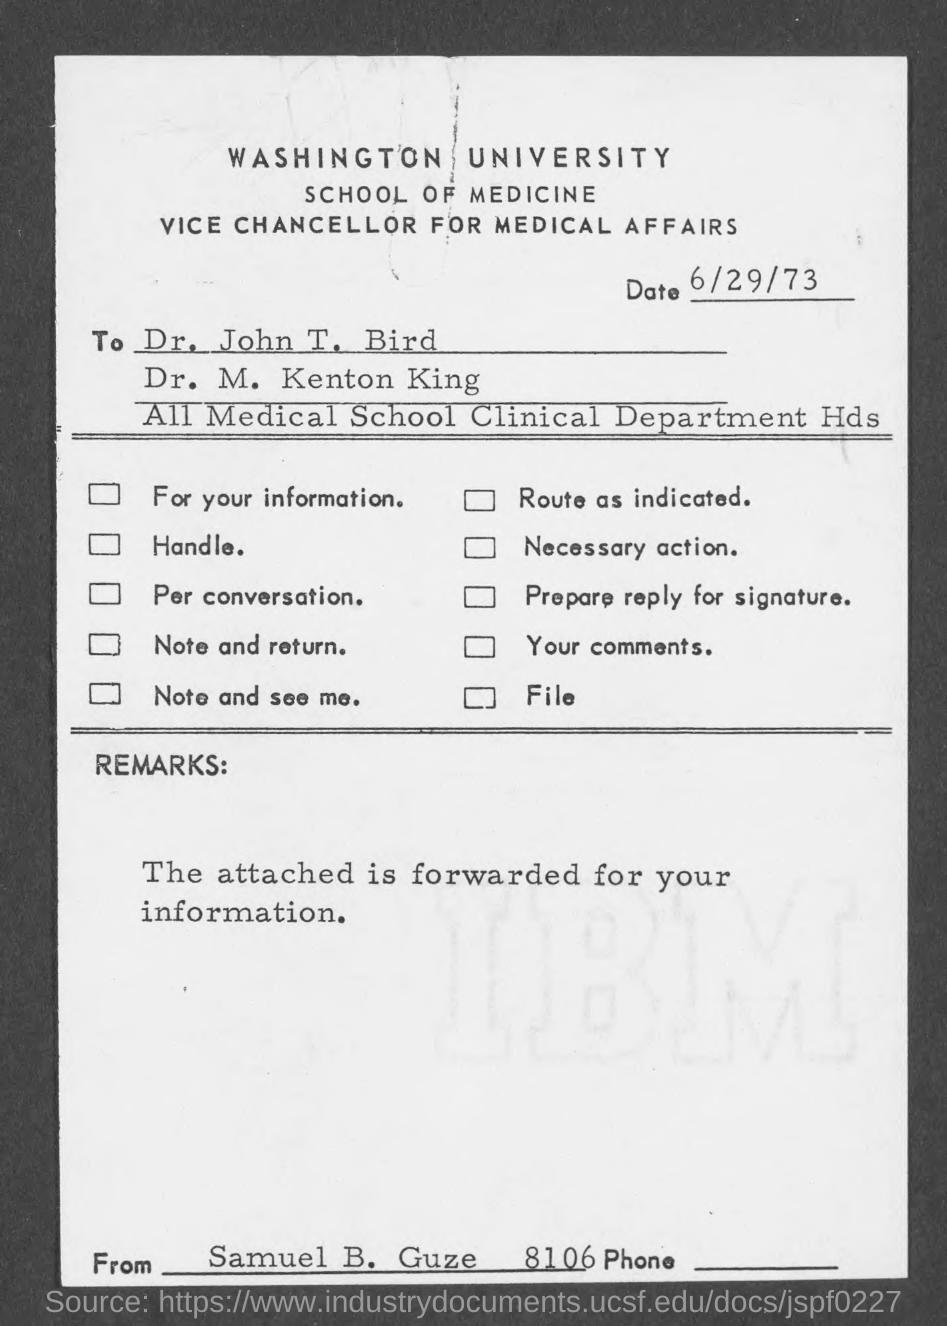What is the date?
Offer a terse response. 6/29/73. Who wrote the letter?
Your answer should be very brief. Samuel B. Guze. 